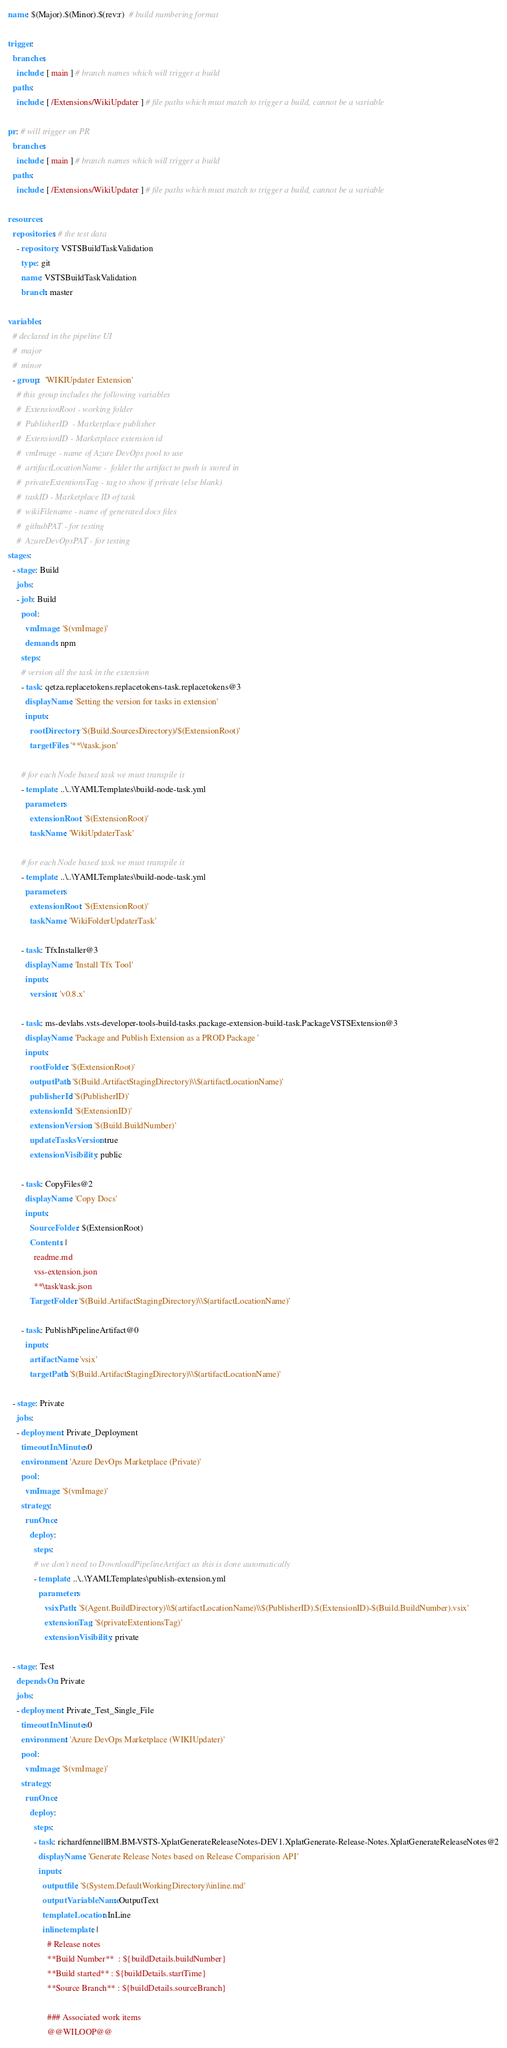<code> <loc_0><loc_0><loc_500><loc_500><_YAML_>name: $(Major).$(Minor).$(rev:r)  # build numbering format

trigger:
  branches:
    include: [ main ] # branch names which will trigger a build
  paths:
    include: [ /Extensions/WikiUpdater ] # file paths which must match to trigger a build, cannot be a variable

pr: # will trigger on PR
  branches:
    include: [ main ] # branch names which will trigger a build
  paths:
    include: [ /Extensions/WikiUpdater ] # file paths which must match to trigger a build, cannot be a variable

resources:
  repositories: # the test data
    - repository: VSTSBuildTaskValidation
      type: git
      name: VSTSBuildTaskValidation
      branch: master

variables:
  # declared in the pipeline UI
  #  major
  #  minor
  - group:  'WIKIUpdater Extension'
    # this group includes the following variables
    #  ExtensionRoot - working folder
    #  PublisherID  - Marketplace publisher
    #  ExtensionID - Marketplace extension id
    #  vmImage - name of Azure DevOps pool to use
    #  artifactLocationName -  folder the artifact to push is stored in
    #  privateExtentionsTag - tag to show if private (else blank)
    #  taskID - Marketplace ID of task
    #  wikiFilename - name of generated docs files
    #  githubPAT - for testing
    #  AzureDevOpsPAT - for testing
stages:
  - stage: Build
    jobs:
    - job: Build
      pool:
        vmImage: '$(vmImage)'
        demands: npm
      steps:
      # version all the task in the extension
      - task: qetza.replacetokens.replacetokens-task.replacetokens@3
        displayName: 'Setting the version for tasks in extension'
        inputs:
          rootDirectory: '$(Build.SourcesDirectory)/$(ExtensionRoot)'
          targetFiles: '**\\task.json'

      # for each Node based task we must transpile it
      - template: ..\..\YAMLTemplates\build-node-task.yml
        parameters:
          extensionRoot: '$(ExtensionRoot)'
          taskName: 'WikiUpdaterTask'

      # for each Node based task we must transpile it
      - template: ..\..\YAMLTemplates\build-node-task.yml
        parameters:
          extensionRoot: '$(ExtensionRoot)'
          taskName: 'WikiFolderUpdaterTask'

      - task: TfxInstaller@3
        displayName: 'Install Tfx Tool'
        inputs:
          version: 'v0.8.x'

      - task: ms-devlabs.vsts-developer-tools-build-tasks.package-extension-build-task.PackageVSTSExtension@3
        displayName: 'Package and Publish Extension as a PROD Package '
        inputs:
          rootFolder: '$(ExtensionRoot)'
          outputPath: '$(Build.ArtifactStagingDirectory)\\$(artifactLocationName)'
          publisherId: '$(PublisherID)'
          extensionId: '$(ExtensionID)'
          extensionVersion: '$(Build.BuildNumber)'
          updateTasksVersion: true
          extensionVisibility: public

      - task: CopyFiles@2
        displayName: 'Copy Docs'
        inputs:
          SourceFolder: $(ExtensionRoot)
          Contents: |
            readme.md
            vss-extension.json
            **\task\task.json
          TargetFolder: '$(Build.ArtifactStagingDirectory)\\$(artifactLocationName)'

      - task: PublishPipelineArtifact@0
        inputs:
          artifactName: 'vsix'
          targetPath: '$(Build.ArtifactStagingDirectory)\\$(artifactLocationName)'

  - stage: Private
    jobs:
    - deployment: Private_Deployment
      timeoutInMinutes: 0
      environment: 'Azure DevOps Marketplace (Private)'
      pool:
        vmImage: '$(vmImage)'
      strategy:
        runOnce:
          deploy:
            steps:
            # we don't need to DownloadPipelineArtifact as this is done automatically
            - template: ..\..\YAMLTemplates\publish-extension.yml
              parameters:
                 vsixPath: '$(Agent.BuildDirectory)\\$(artifactLocationName)\\$(PublisherID).$(ExtensionID)-$(Build.BuildNumber).vsix'
                 extensionTag: '$(privateExtentionsTag)'
                 extensionVisibility: private

  - stage: Test
    dependsOn: Private
    jobs:
    - deployment: Private_Test_Single_File
      timeoutInMinutes: 0
      environment: 'Azure DevOps Marketplace (WIKIUpdater)'
      pool:
        vmImage: '$(vmImage)'
      strategy:
        runOnce:
          deploy:
            steps:
            - task: richardfennellBM.BM-VSTS-XplatGenerateReleaseNotes-DEV1.XplatGenerate-Release-Notes.XplatGenerateReleaseNotes@2
              displayName: 'Generate Release Notes based on Release Comparision API'
              inputs:
                outputfile: '$(System.DefaultWorkingDirectory)\inline.md'
                outputVariableName: OutputText
                templateLocation: InLine
                inlinetemplate: |
                  # Release notes
                  **Build Number**  : ${buildDetails.buildNumber}
                  **Build started** : ${buildDetails.startTime}
                  **Source Branch** : ${buildDetails.sourceBranch}

                  ### Associated work items
                  @@WILOOP@@</code> 